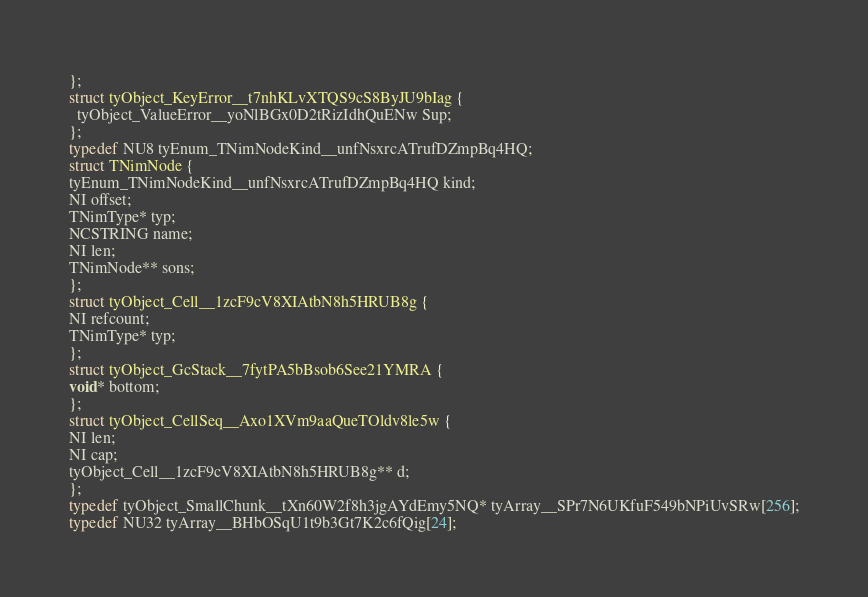Convert code to text. <code><loc_0><loc_0><loc_500><loc_500><_C_>};
struct tyObject_KeyError__t7nhKLvXTQS9cS8ByJU9bIag {
  tyObject_ValueError__yoNlBGx0D2tRizIdhQuENw Sup;
};
typedef NU8 tyEnum_TNimNodeKind__unfNsxrcATrufDZmpBq4HQ;
struct TNimNode {
tyEnum_TNimNodeKind__unfNsxrcATrufDZmpBq4HQ kind;
NI offset;
TNimType* typ;
NCSTRING name;
NI len;
TNimNode** sons;
};
struct tyObject_Cell__1zcF9cV8XIAtbN8h5HRUB8g {
NI refcount;
TNimType* typ;
};
struct tyObject_GcStack__7fytPA5bBsob6See21YMRA {
void* bottom;
};
struct tyObject_CellSeq__Axo1XVm9aaQueTOldv8le5w {
NI len;
NI cap;
tyObject_Cell__1zcF9cV8XIAtbN8h5HRUB8g** d;
};
typedef tyObject_SmallChunk__tXn60W2f8h3jgAYdEmy5NQ* tyArray__SPr7N6UKfuF549bNPiUvSRw[256];
typedef NU32 tyArray__BHbOSqU1t9b3Gt7K2c6fQig[24];</code> 